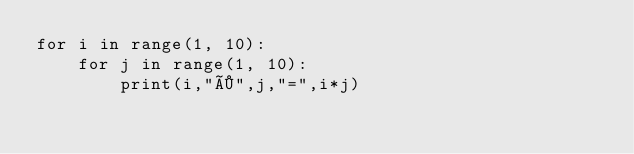<code> <loc_0><loc_0><loc_500><loc_500><_Python_>for i in range(1, 10):
    for j in range(1, 10):
        print(i,"×",j,"=",i*j)
        
</code> 